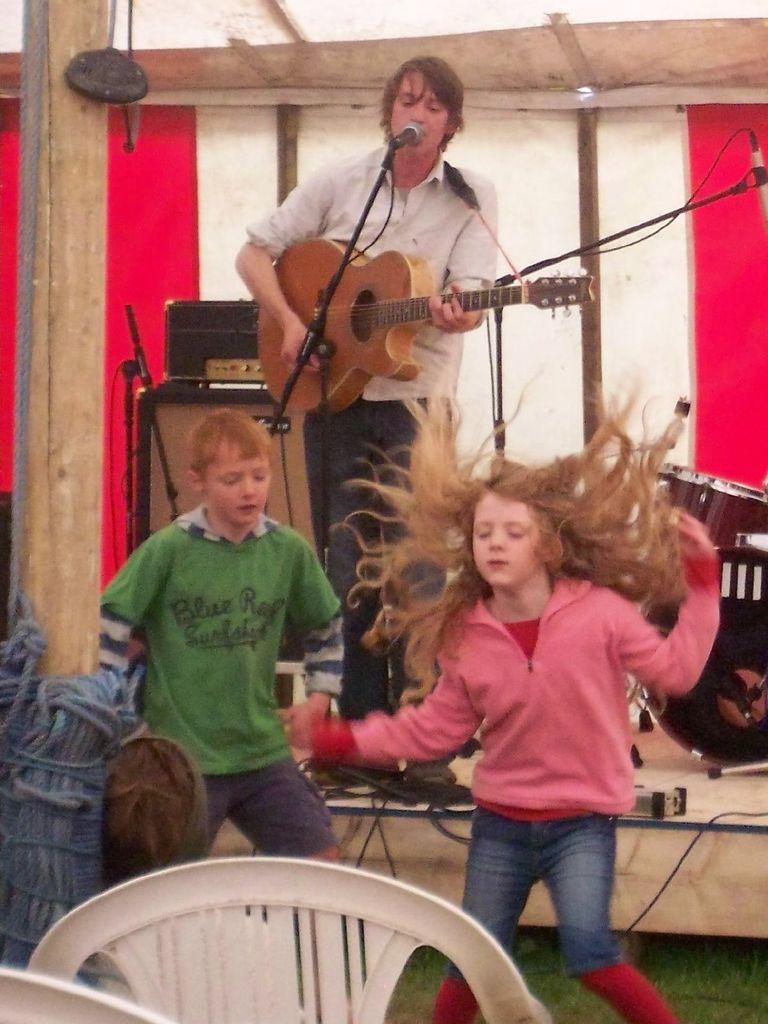How would you summarize this image in a sentence or two? here in this picture we can see a person standing on the stage holding a guitar with a micro phone in front of him,here we can also see a children dancing ,here we can see the chairs ,here we can also see different different musical instruments. 